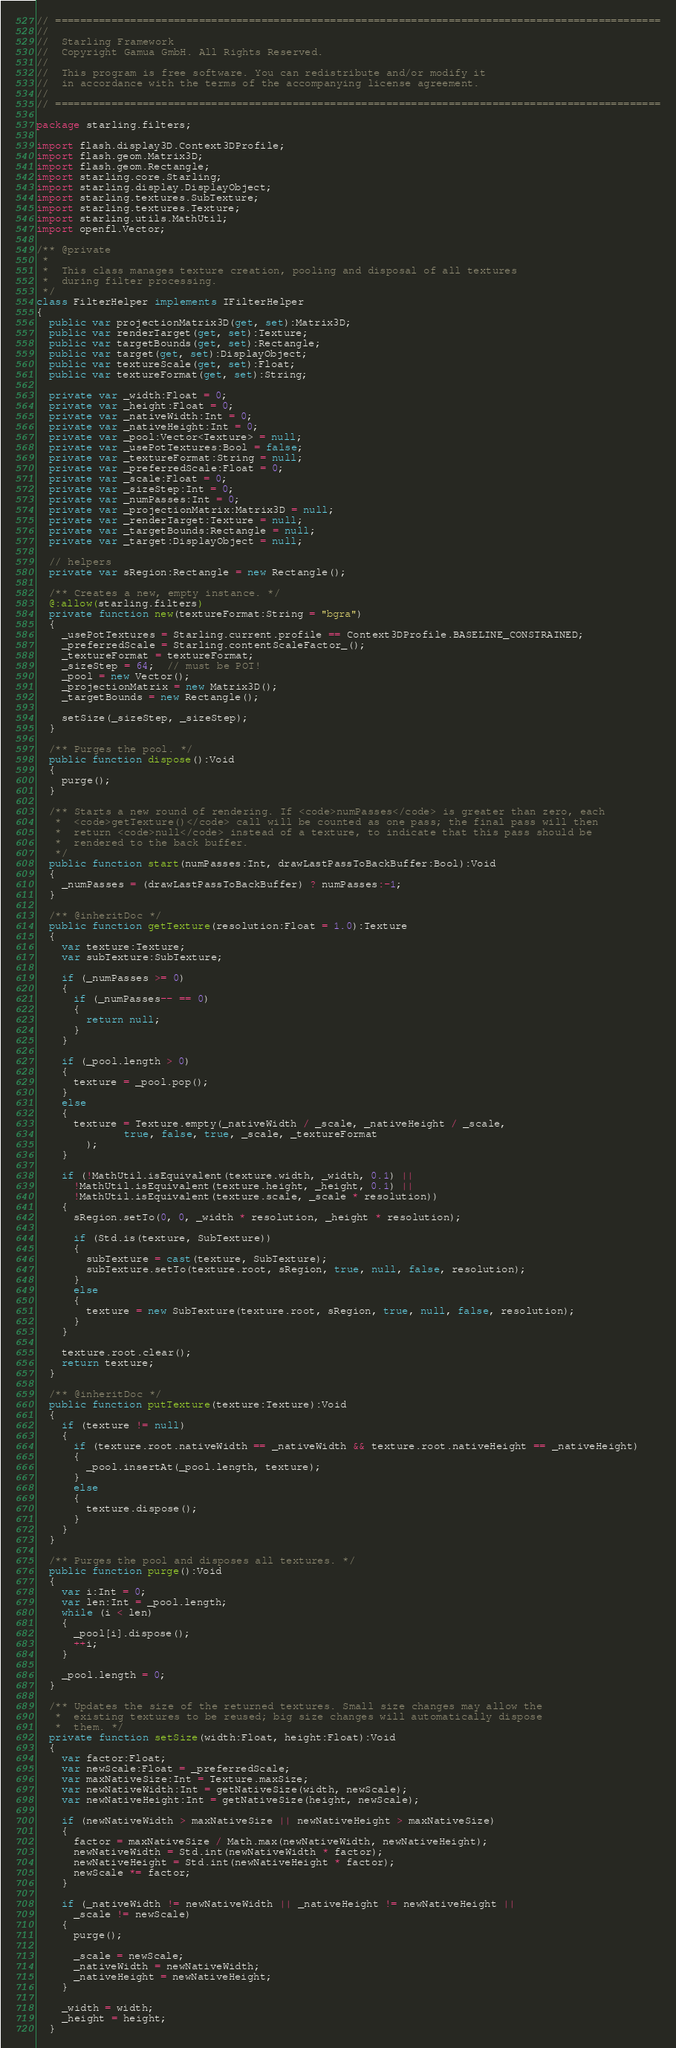Convert code to text. <code><loc_0><loc_0><loc_500><loc_500><_Haxe_>// =================================================================================================
//
//	Starling Framework
//	Copyright Gamua GmbH. All Rights Reserved.
//
//	This program is free software. You can redistribute and/or modify it
//	in accordance with the terms of the accompanying license agreement.
//
// =================================================================================================

package starling.filters;

import flash.display3D.Context3DProfile;
import flash.geom.Matrix3D;
import flash.geom.Rectangle;
import starling.core.Starling;
import starling.display.DisplayObject;
import starling.textures.SubTexture;
import starling.textures.Texture;
import starling.utils.MathUtil;
import openfl.Vector;

/** @private
 *
 *  This class manages texture creation, pooling and disposal of all textures
 *  during filter processing.
 */
class FilterHelper implements IFilterHelper
{
  public var projectionMatrix3D(get, set):Matrix3D;
  public var renderTarget(get, set):Texture;
  public var targetBounds(get, set):Rectangle;
  public var target(get, set):DisplayObject;
  public var textureScale(get, set):Float;
  public var textureFormat(get, set):String;

  private var _width:Float = 0;
  private var _height:Float = 0;
  private var _nativeWidth:Int = 0;
  private var _nativeHeight:Int = 0;
  private var _pool:Vector<Texture> = null;
  private var _usePotTextures:Bool = false;
  private var _textureFormat:String = null;
  private var _preferredScale:Float = 0;
  private var _scale:Float = 0;
  private var _sizeStep:Int = 0;
  private var _numPasses:Int = 0;
  private var _projectionMatrix:Matrix3D = null;
  private var _renderTarget:Texture = null;
  private var _targetBounds:Rectangle = null;
  private var _target:DisplayObject = null;

  // helpers
  private var sRegion:Rectangle = new Rectangle();

  /** Creates a new, empty instance. */
  @:allow(starling.filters)
  private function new(textureFormat:String = "bgra")
  {
    _usePotTextures = Starling.current.profile == Context3DProfile.BASELINE_CONSTRAINED;
    _preferredScale = Starling.contentScaleFactor_();
    _textureFormat = textureFormat;
    _sizeStep = 64;  // must be POT!
    _pool = new Vector();
    _projectionMatrix = new Matrix3D();
    _targetBounds = new Rectangle();

    setSize(_sizeStep, _sizeStep);
  }

  /** Purges the pool. */
  public function dispose():Void
  {
    purge();
  }

  /** Starts a new round of rendering. If <code>numPasses</code> is greater than zero, each
   *  <code>getTexture()</code> call will be counted as one pass; the final pass will then
   *  return <code>null</code> instead of a texture, to indicate that this pass should be
   *  rendered to the back buffer.
   */
  public function start(numPasses:Int, drawLastPassToBackBuffer:Bool):Void
  {
    _numPasses = (drawLastPassToBackBuffer) ? numPasses:-1;
  }

  /** @inheritDoc */
  public function getTexture(resolution:Float = 1.0):Texture
  {
    var texture:Texture;
    var subTexture:SubTexture;

    if (_numPasses >= 0)
    {
      if (_numPasses-- == 0)
      {
        return null;
      }
    }

    if (_pool.length > 0)
    {
      texture = _pool.pop();
    }
    else
    {
      texture = Texture.empty(_nativeWidth / _scale, _nativeHeight / _scale,
              true, false, true, _scale, _textureFormat
        );
    }

    if (!MathUtil.isEquivalent(texture.width, _width, 0.1) ||
      !MathUtil.isEquivalent(texture.height, _height, 0.1) ||
      !MathUtil.isEquivalent(texture.scale, _scale * resolution))
    {
      sRegion.setTo(0, 0, _width * resolution, _height * resolution);

      if (Std.is(texture, SubTexture))
      {
        subTexture = cast(texture, SubTexture);
        subTexture.setTo(texture.root, sRegion, true, null, false, resolution);
      }
      else
      {
        texture = new SubTexture(texture.root, sRegion, true, null, false, resolution);
      }
    }

    texture.root.clear();
    return texture;
  }

  /** @inheritDoc */
  public function putTexture(texture:Texture):Void
  {
    if (texture != null)
    {
      if (texture.root.nativeWidth == _nativeWidth && texture.root.nativeHeight == _nativeHeight)
      {
        _pool.insertAt(_pool.length, texture);
      }
      else
      {
        texture.dispose();
      }
    }
  }

  /** Purges the pool and disposes all textures. */
  public function purge():Void
  {
    var i:Int = 0;
    var len:Int = _pool.length;
    while (i < len)
    {
      _pool[i].dispose();
      ++i;
    }

    _pool.length = 0;
  }

  /** Updates the size of the returned textures. Small size changes may allow the
   *  existing textures to be reused; big size changes will automatically dispose
   *  them. */
  private function setSize(width:Float, height:Float):Void
  {
    var factor:Float;
    var newScale:Float = _preferredScale;
    var maxNativeSize:Int = Texture.maxSize;
    var newNativeWidth:Int = getNativeSize(width, newScale);
    var newNativeHeight:Int = getNativeSize(height, newScale);

    if (newNativeWidth > maxNativeSize || newNativeHeight > maxNativeSize)
    {
      factor = maxNativeSize / Math.max(newNativeWidth, newNativeHeight);
      newNativeWidth = Std.int(newNativeWidth * factor);
      newNativeHeight = Std.int(newNativeHeight * factor);
      newScale *= factor;
    }

    if (_nativeWidth != newNativeWidth || _nativeHeight != newNativeHeight ||
      _scale != newScale)
    {
      purge();

      _scale = newScale;
      _nativeWidth = newNativeWidth;
      _nativeHeight = newNativeHeight;
    }

    _width = width;
    _height = height;
  }
</code> 